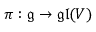<formula> <loc_0><loc_0><loc_500><loc_500>\pi \colon { \mathfrak { g } } \to { \mathfrak { g l } } ( V )</formula> 